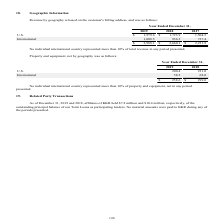According to Godaddy's financial document, What information does the table show? Property and equipment, net by geography. The document states: "Property and equipment, net by geography was as follows:..." Also, What are the two geographic regions listed in the table? The document shows two values: U.S. and International. From the document: "2019 2018 U.S. 200.4 231.0 International 58.2 68.0 2019 2018 U.S. 200.4 231.0 International 58.2 68.0..." Also, Which financial years' information is shown in the table? The document shows two values: 2018 and 2019. From the document: "Year Ended December 31, 2019 2018 2017 U.S. $ 1,979.6 $ 1,723.9 1,504.5 International 1,008.5 936.2 727.4 $ 2,988.1 $ 2,660.1 $ Year Ended December 31..." Also, can you calculate: What is the average net property and equipment for 2018 and 2019 in U.S? To answer this question, I need to perform calculations using the financial data. The calculation is: (200.4+231.0)/2, which equals 215.7. This is based on the information: "2019 2018 U.S. 200.4 231.0 International 58.2 68.0 2019 2018 U.S. 200.4 231.0 International 58.2 68.0..." The key data points involved are: 200.4, 231.0. Also, can you calculate: What is the average net property and equipment for 2018 and 2019 Internationally? To answer this question, I need to perform calculations using the financial data. The calculation is: (58.2+68.0)/2, which equals 63.1. This is based on the information: "2019 2018 U.S. 200.4 231.0 International 58.2 68.0 2019 2018 U.S. 200.4 231.0 International 58.2 68.0..." The key data points involved are: 58.2, 68.0. Additionally, Between 2018 and 2019, which year has higher net property and equipment in U.S.? According to the financial document, 2018. The relevant text states: "Year Ended December 31, 2019 2018 2017 U.S. $ 1,979.6 $ 1,723.9 1,504.5 International 1,008.5 936.2 727.4 $ 2,988.1 $ 2,660.1 $ 2,231..." 